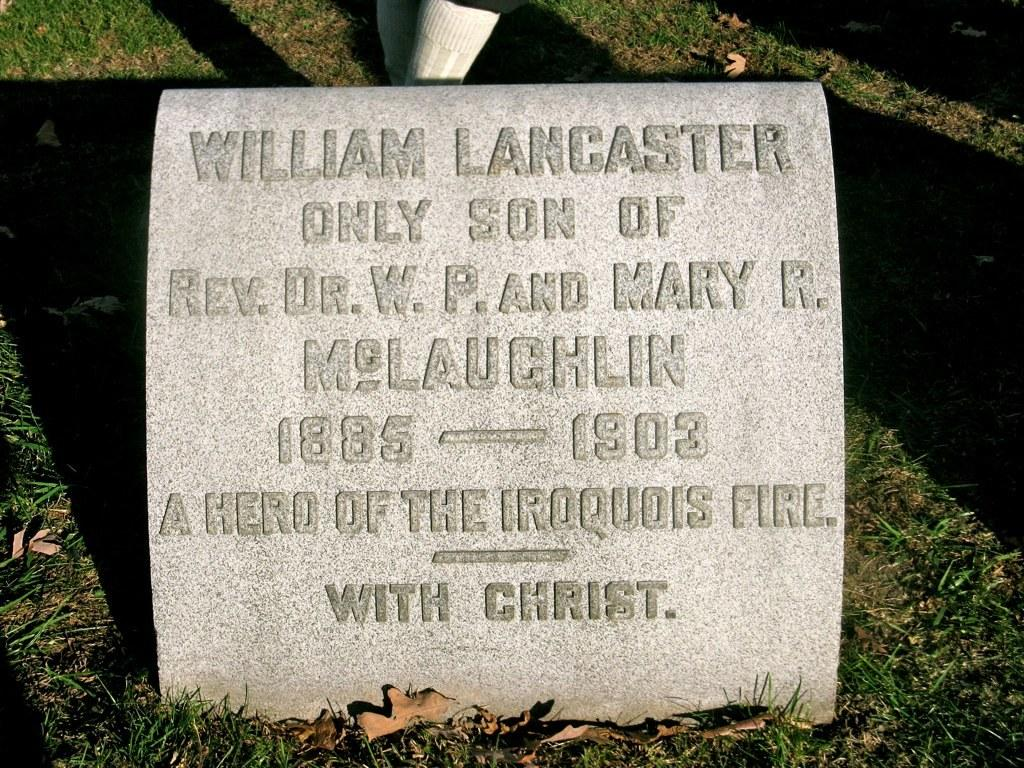What is written on in the image? There is text on a stone in the image. Where is the stone located? The stone is on the grass. What can be seen in the background of the image? People's legs with socks are visible in the background. What type of vegetation is present in the image? Dried leaves are present in the image. What type of competition is taking place in the image? There is no competition present in the image. Can you see a rabbit in the image? There is no rabbit present in the image. 